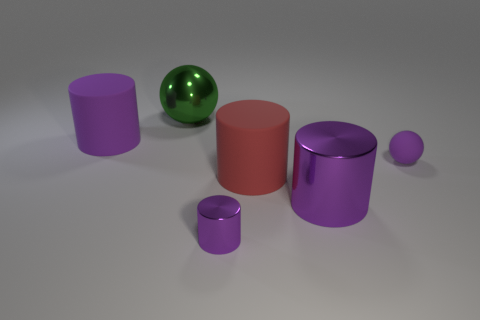Subtract all purple cubes. How many purple cylinders are left? 3 Add 4 large green things. How many objects exist? 10 Subtract all balls. How many objects are left? 4 Add 5 big rubber things. How many big rubber things are left? 7 Add 4 purple cylinders. How many purple cylinders exist? 7 Subtract 0 blue cylinders. How many objects are left? 6 Subtract all brown metallic cubes. Subtract all red rubber cylinders. How many objects are left? 5 